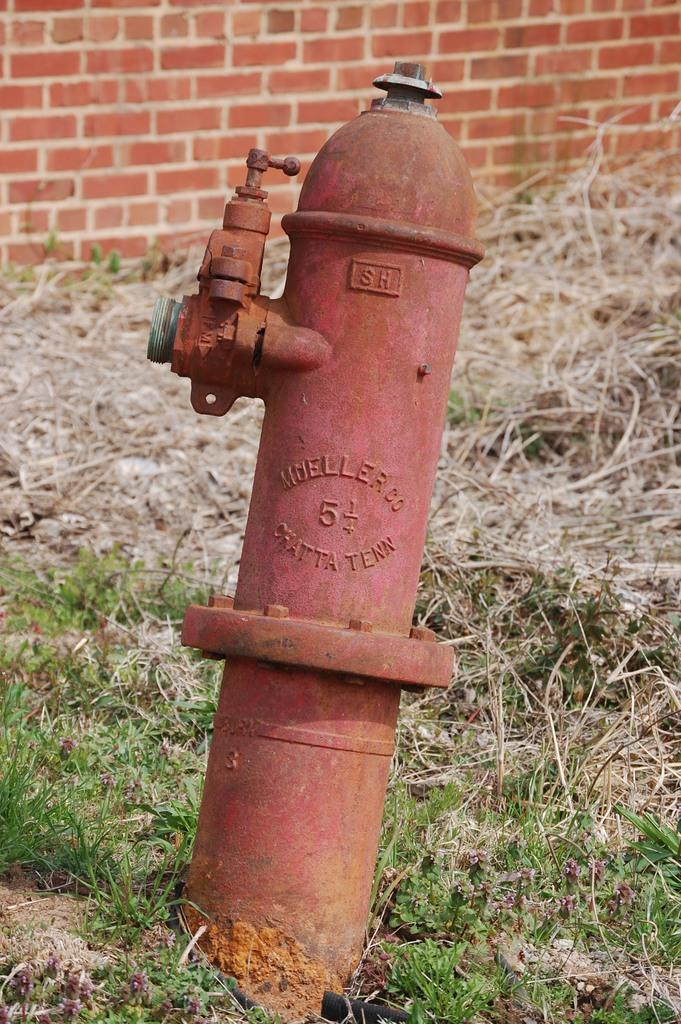What is located on the ground in the image? There is a standpipe on the ground in the image. What type of vegetation is present on the ground in the image? There is grass on the ground in the image. What can be seen in the background of the image? There is a brick wall in the background of the image. Is there a volcano visible in the image? No, there is no volcano present in the image. What type of basin is used to collect water from the standpipe in the image? The image does not show any basin or water collection system associated with the standpipe. 